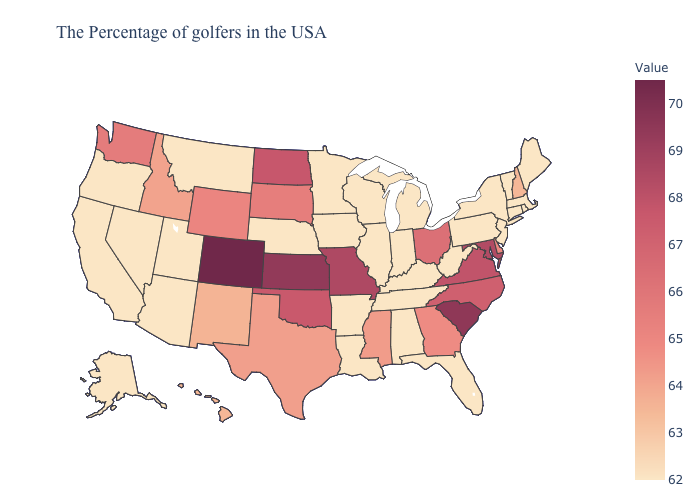Which states have the lowest value in the West?
Be succinct. Utah, Montana, Arizona, Nevada, California, Oregon, Alaska. Which states hav the highest value in the West?
Write a very short answer. Colorado. Which states hav the highest value in the Northeast?
Concise answer only. New Hampshire. Among the states that border Florida , does Alabama have the highest value?
Short answer required. No. 